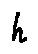<formula> <loc_0><loc_0><loc_500><loc_500>h</formula> 